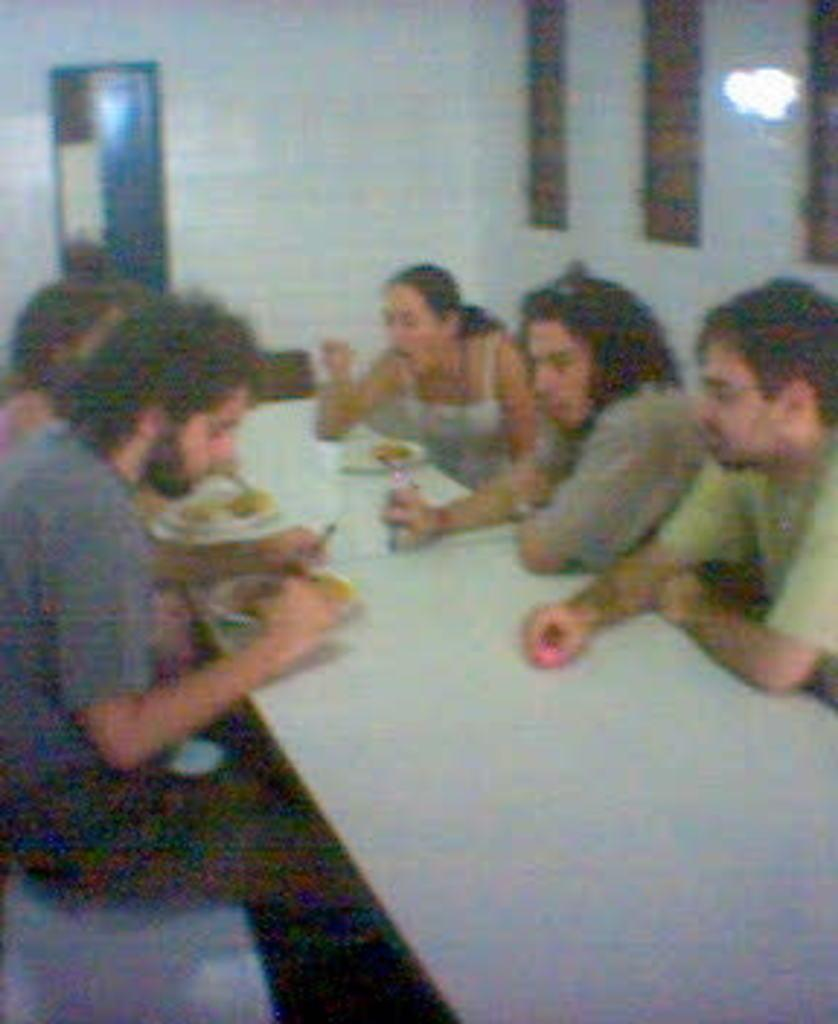How many people are in the image? There are several people in the image. What are the people doing in the image? The people are sitting on a white table. What else can be seen on the table besides the people? There are food eatables on the table. What is visible in the background of the image? There is a glass window in the background of the image. What type of jeans is the person wearing in the image? There is no information about jeans in the image, as the focus is on the people sitting on the white table and the food eatables. 